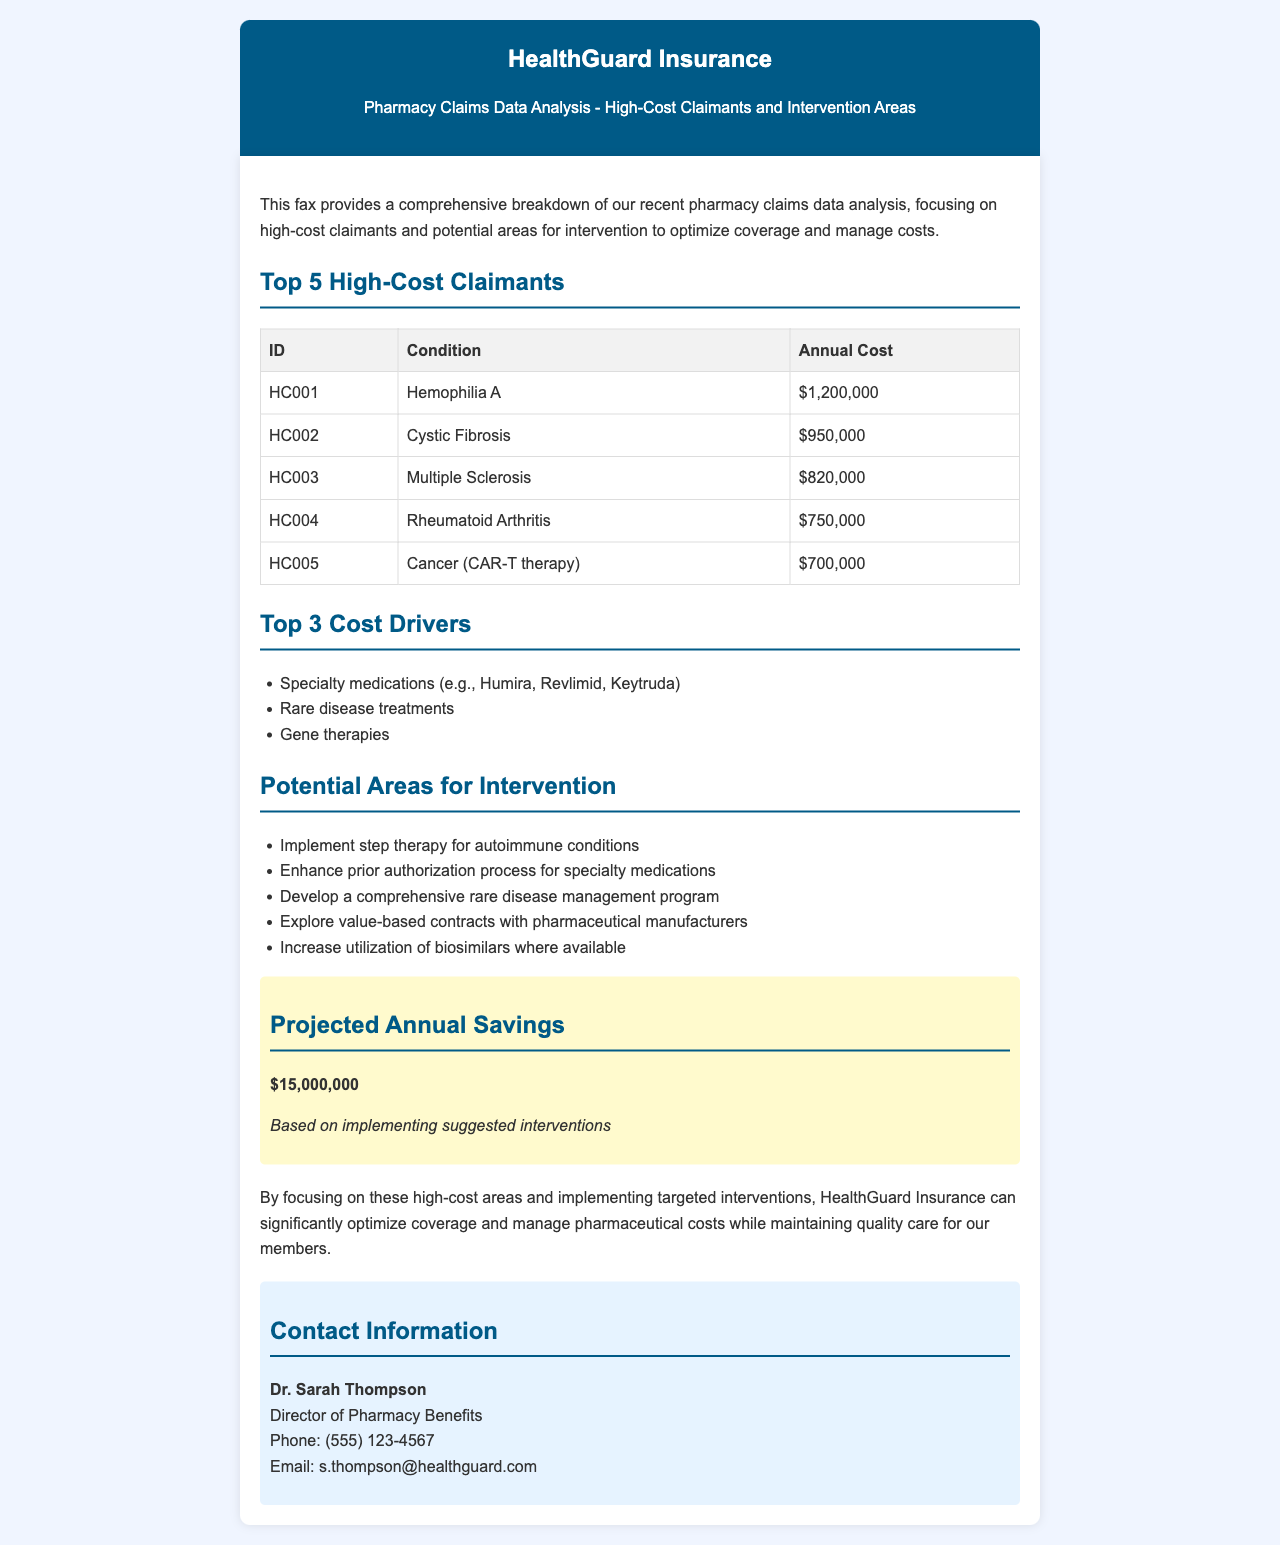What is the annual cost for the highest claimant? The annual cost for the highest claimant, who has Hemophilia A, is mentioned in the table as $1,200,000.
Answer: $1,200,000 What condition is associated with ID HC002? The condition associated with ID HC002 is listed in the table as Cystic Fibrosis.
Answer: Cystic Fibrosis What are the top three cost drivers? The document lists the top three cost drivers in a bullet list as specialty medications, rare disease treatments, and gene therapies.
Answer: Specialty medications, rare disease treatments, gene therapies How much projected annual savings could be achieved? The projected annual savings based on suggested interventions is stated in the document as $15,000,000.
Answer: $15,000,000 What intervention involves 'step therapy'? The potential area for intervention that involves 'step therapy' is specifically noted for autoimmune conditions in the document.
Answer: Autoimmune conditions 